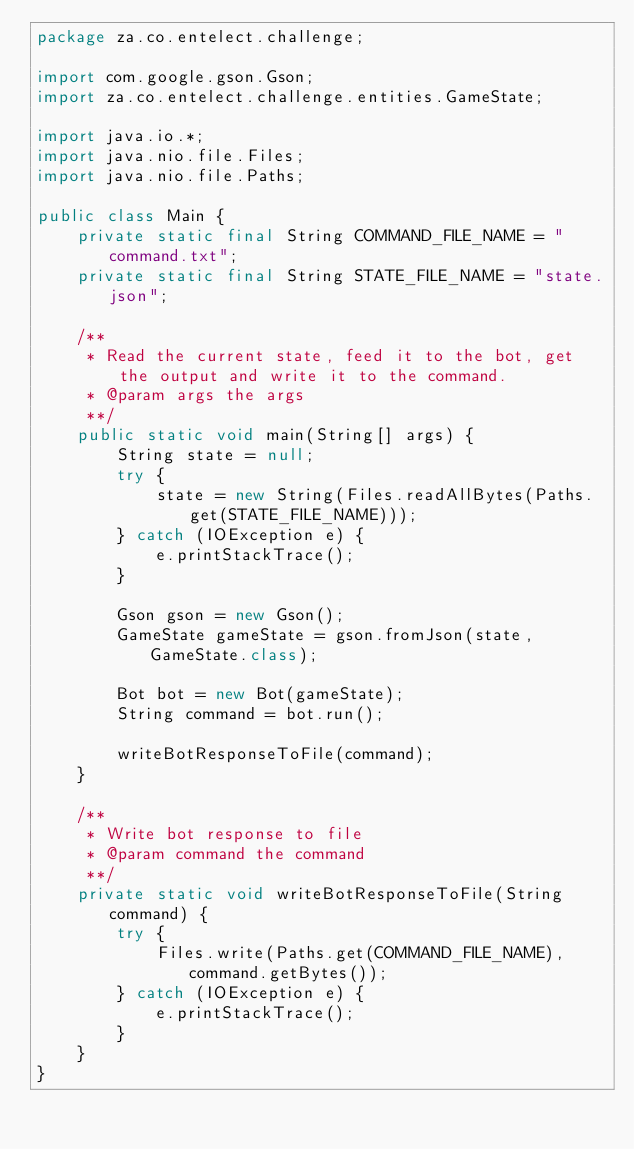<code> <loc_0><loc_0><loc_500><loc_500><_Java_>package za.co.entelect.challenge;

import com.google.gson.Gson;
import za.co.entelect.challenge.entities.GameState;

import java.io.*;
import java.nio.file.Files;
import java.nio.file.Paths;

public class Main {
    private static final String COMMAND_FILE_NAME = "command.txt";
    private static final String STATE_FILE_NAME = "state.json";

    /**
     * Read the current state, feed it to the bot, get the output and write it to the command.
     * @param args the args
     **/
    public static void main(String[] args) {
        String state = null;
        try {
            state = new String(Files.readAllBytes(Paths.get(STATE_FILE_NAME)));
        } catch (IOException e) {
            e.printStackTrace();
        }

        Gson gson = new Gson();
        GameState gameState = gson.fromJson(state, GameState.class);

        Bot bot = new Bot(gameState);
        String command = bot.run();

        writeBotResponseToFile(command);
    }

    /**
     * Write bot response to file
     * @param command the command
     **/
    private static void writeBotResponseToFile(String command) {
        try {
            Files.write(Paths.get(COMMAND_FILE_NAME), command.getBytes());
        } catch (IOException e) {
            e.printStackTrace();
        }
    }
}
</code> 